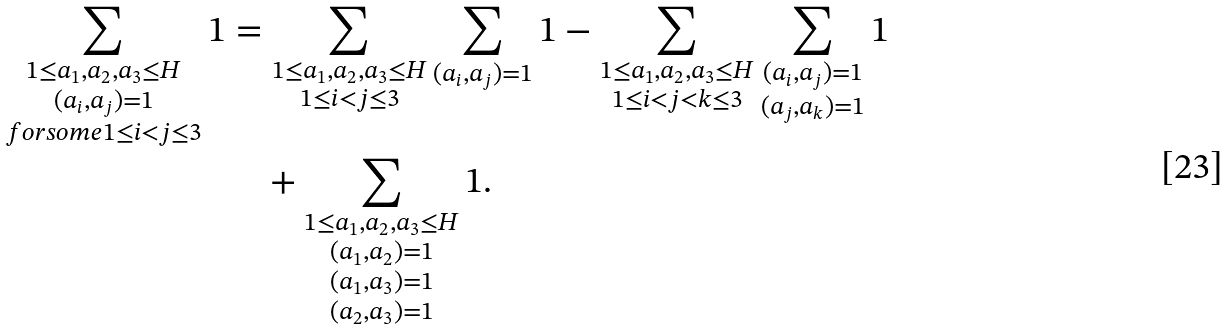Convert formula to latex. <formula><loc_0><loc_0><loc_500><loc_500>\sum _ { \substack { 1 \leq a _ { 1 } , a _ { 2 } , a _ { 3 } \leq H \\ ( a _ { i } , a _ { j } ) = 1 \\ f o r s o m e 1 \leq i < j \leq 3 } } 1 & = \sum _ { \substack { 1 \leq a _ { 1 } , a _ { 2 } , a _ { 3 } \leq H \\ 1 \leq i < j \leq 3 } } \sum _ { ( a _ { i } , a _ { j } ) = 1 } 1 - \sum _ { \substack { 1 \leq a _ { 1 } , a _ { 2 } , a _ { 3 } \leq H \\ 1 \leq i < j < k \leq 3 } } \sum _ { \substack { ( a _ { i } , a _ { j } ) = 1 \\ ( a _ { j } , a _ { k } ) = 1 } } 1 \\ & \quad + \sum _ { \substack { 1 \leq a _ { 1 } , a _ { 2 } , a _ { 3 } \leq H \\ ( a _ { 1 } , a _ { 2 } ) = 1 \\ ( a _ { 1 } , a _ { 3 } ) = 1 \\ ( a _ { 2 } , a _ { 3 } ) = 1 } } 1 .</formula> 